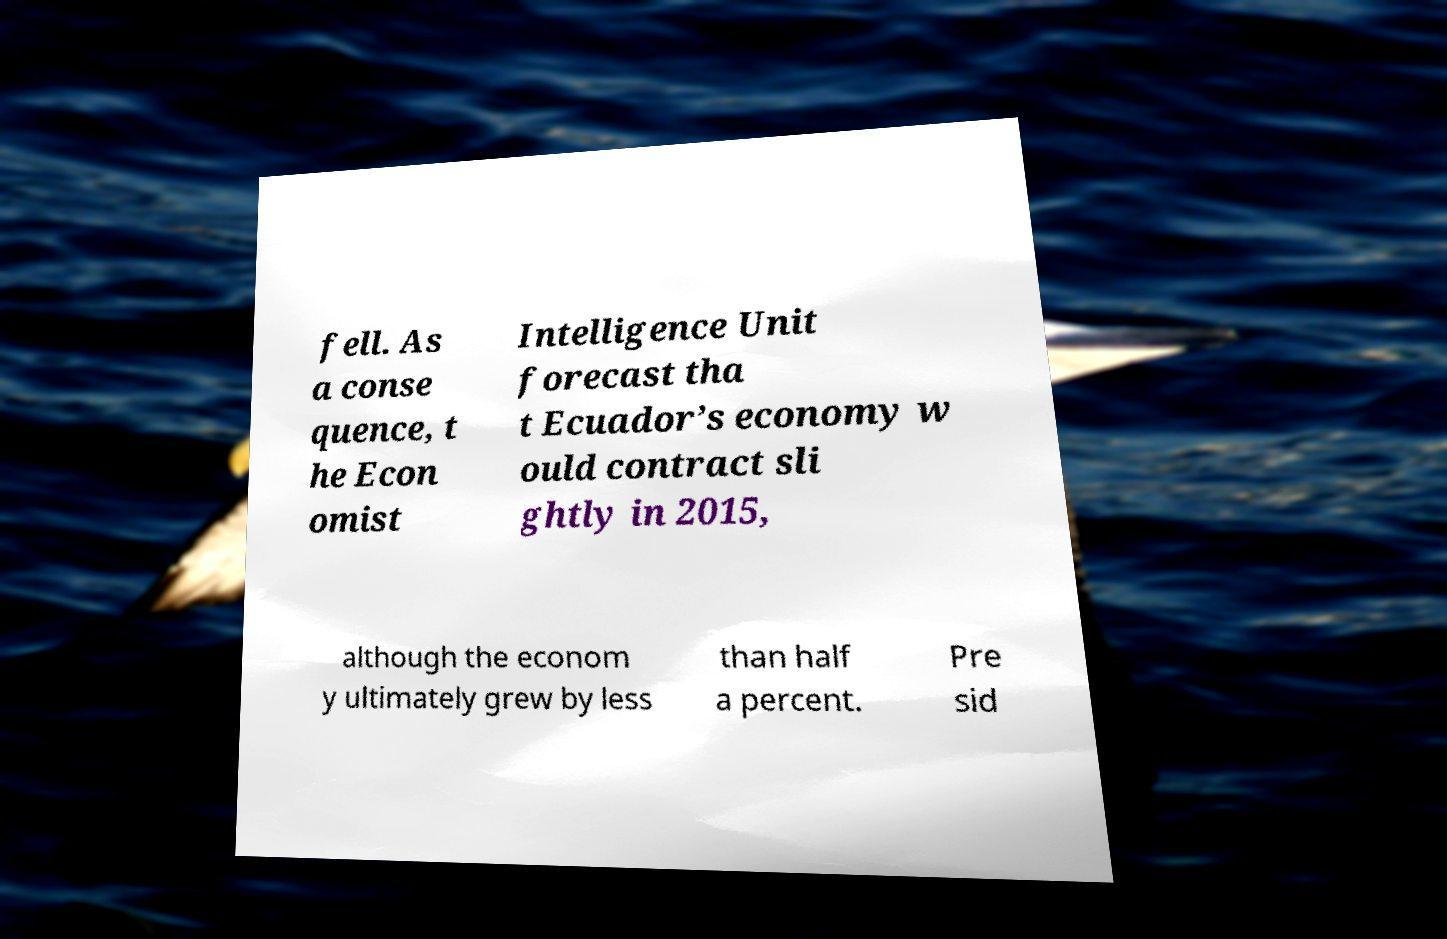Please read and relay the text visible in this image. What does it say? fell. As a conse quence, t he Econ omist Intelligence Unit forecast tha t Ecuador’s economy w ould contract sli ghtly in 2015, although the econom y ultimately grew by less than half a percent. Pre sid 